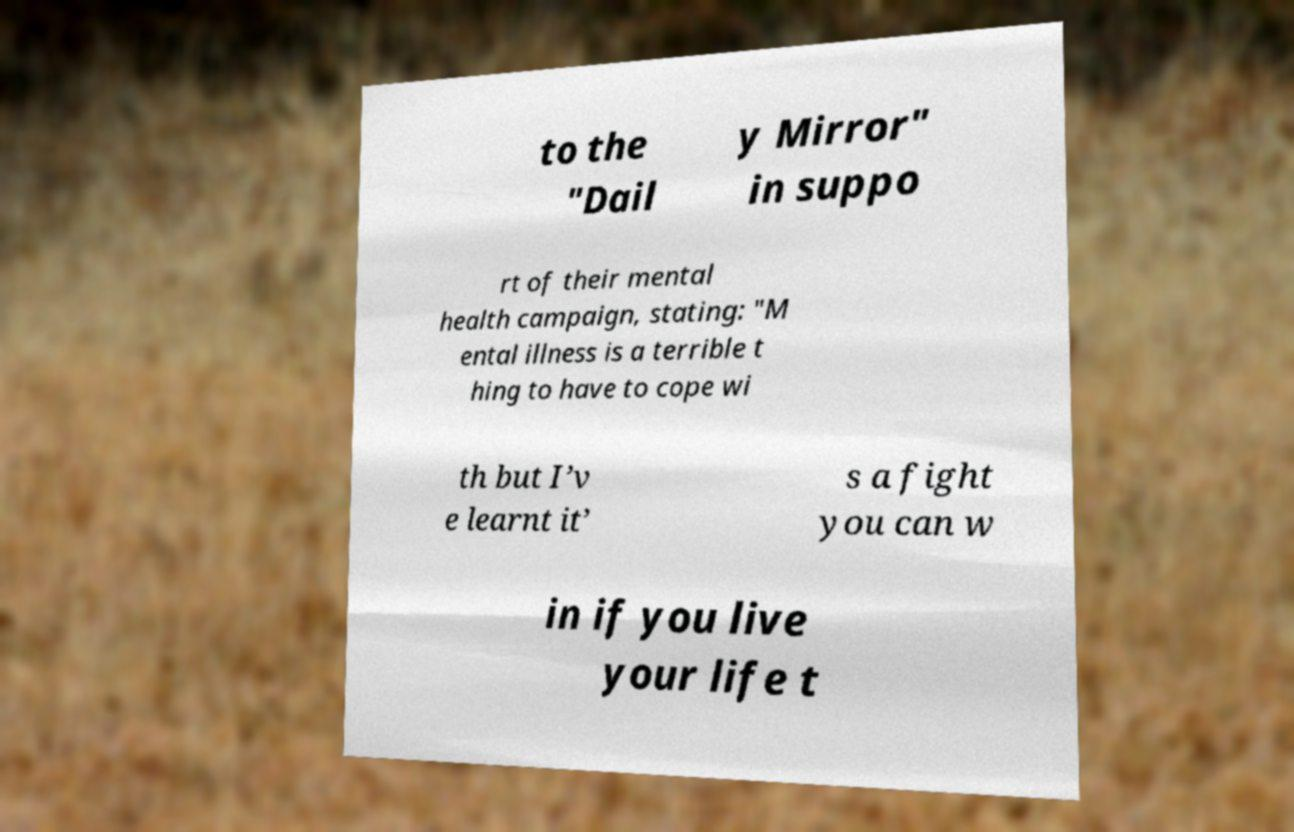What messages or text are displayed in this image? I need them in a readable, typed format. to the "Dail y Mirror" in suppo rt of their mental health campaign, stating: "M ental illness is a terrible t hing to have to cope wi th but I’v e learnt it’ s a fight you can w in if you live your life t 